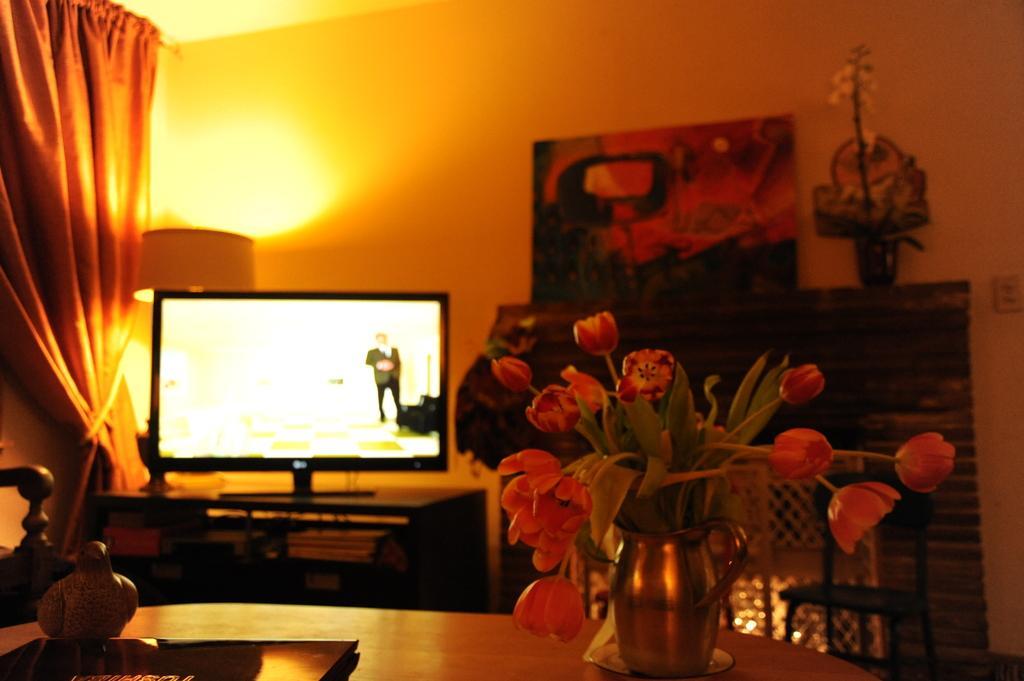How would you summarize this image in a sentence or two? As we can see in the image there is a wall, banner, flower flask, curtain and a screen. 